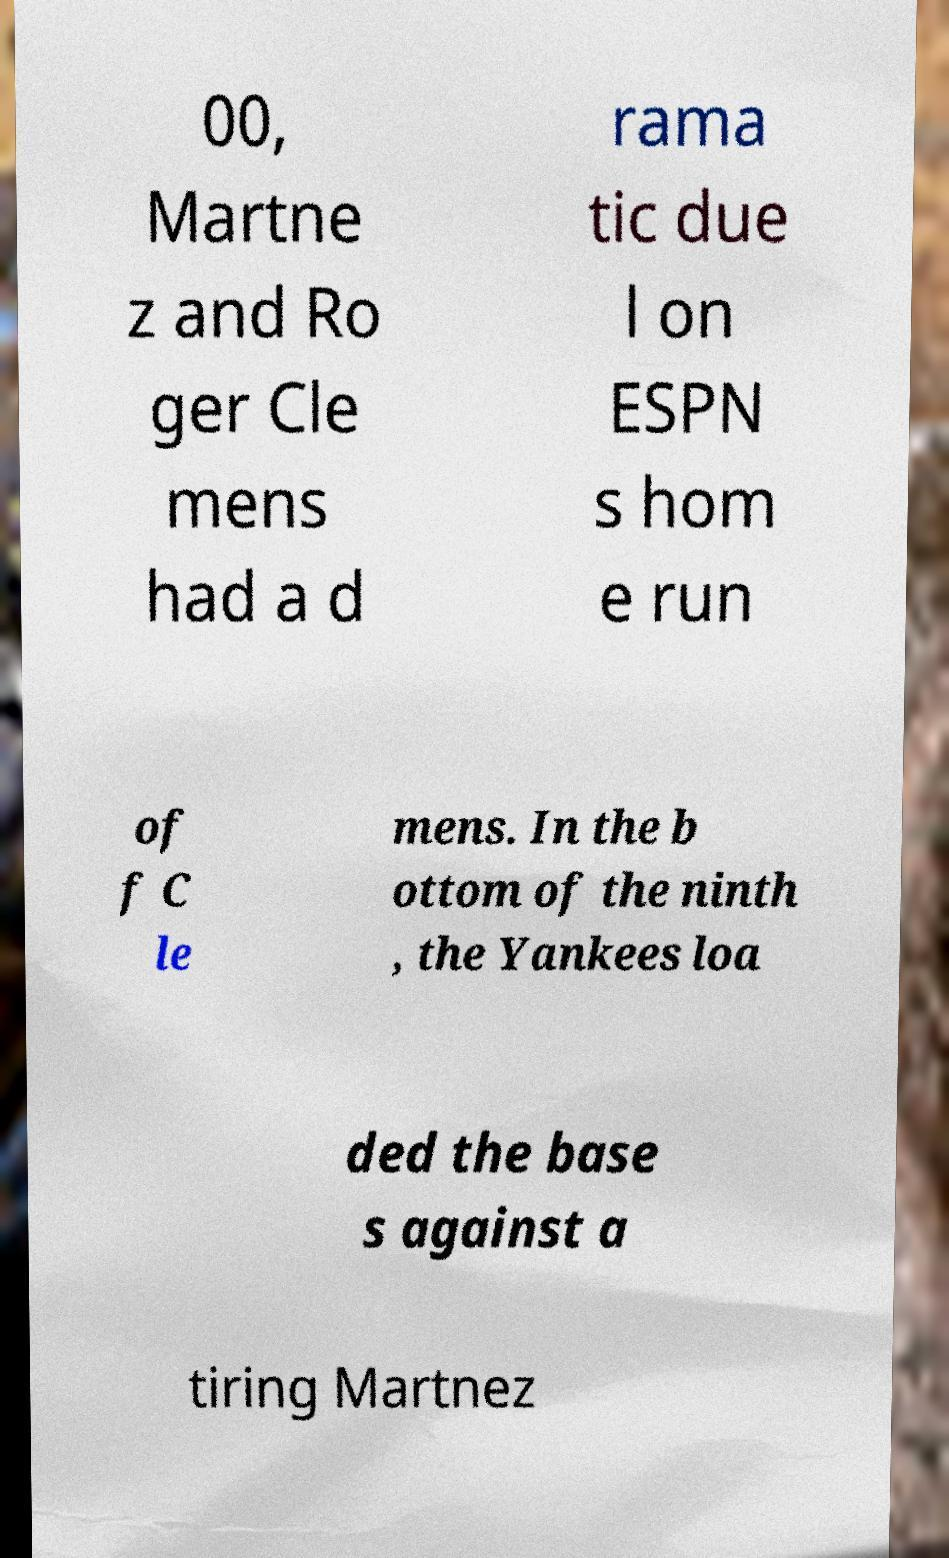There's text embedded in this image that I need extracted. Can you transcribe it verbatim? 00, Martne z and Ro ger Cle mens had a d rama tic due l on ESPN s hom e run of f C le mens. In the b ottom of the ninth , the Yankees loa ded the base s against a tiring Martnez 